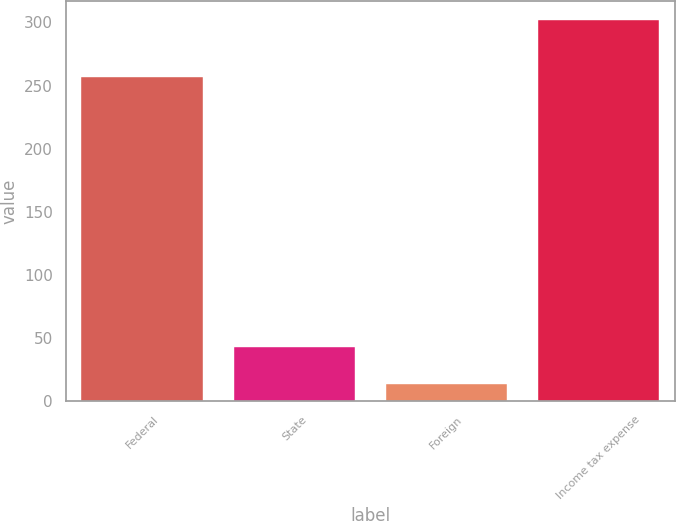Convert chart. <chart><loc_0><loc_0><loc_500><loc_500><bar_chart><fcel>Federal<fcel>State<fcel>Foreign<fcel>Income tax expense<nl><fcel>256.7<fcel>42.5<fcel>13.7<fcel>301.7<nl></chart> 